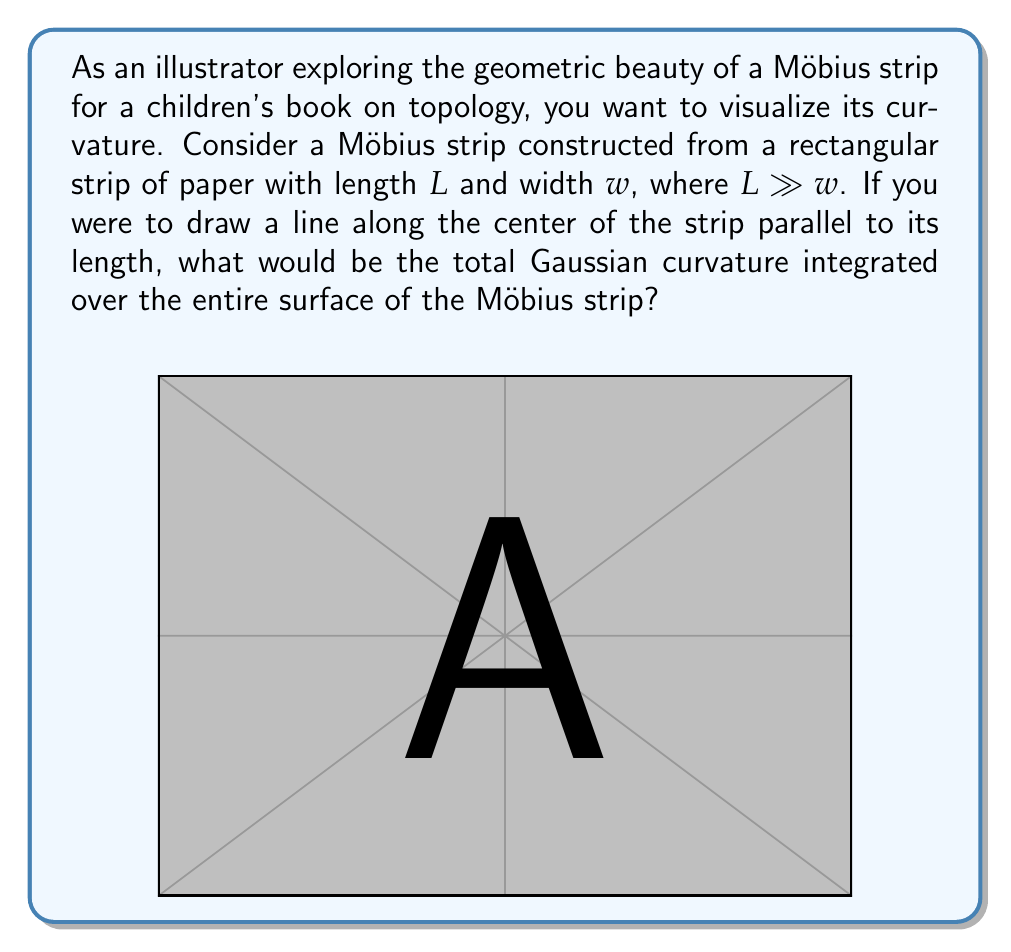Teach me how to tackle this problem. To solve this problem, we need to understand several key concepts:

1) The Gaussian curvature $K$ at a point on a surface is the product of the two principal curvatures at that point.

2) For a Möbius strip, the Gaussian curvature is zero almost everywhere, except along the center line.

3) The total Gaussian curvature of a surface is given by the Gauss-Bonnet theorem:

   $$\int\int_S K dA = 2\pi\chi(S)$$

   where $\chi(S)$ is the Euler characteristic of the surface.

4) The Euler characteristic of a Möbius strip is 0.

5) However, the center line of a Möbius strip contributes to the total curvature.

Let's approach this step-by-step:

1) The Möbius strip is formed by taking a rectangular strip and giving it a half-twist before connecting the ends.

2) Along most of the surface, the Gaussian curvature is zero because one of the principal curvatures (along the width) is always zero.

3) The center line, however, forms a closed curve with a single twist. This is topologically equivalent to a circle in 3D space.

4) The total curvature of a simple closed curve in 3D space is always an integer multiple of $2\pi$. For a curve with one twist, like the center line of a Möbius strip, this multiple is 1.

5) Therefore, the total Gaussian curvature of the Möbius strip comes entirely from this center line and is equal to $2\pi$.

This result is independent of the dimensions of the strip, as long as it's twisted only once.
Answer: The total Gaussian curvature integrated over the entire surface of the Möbius strip is $2\pi$. 